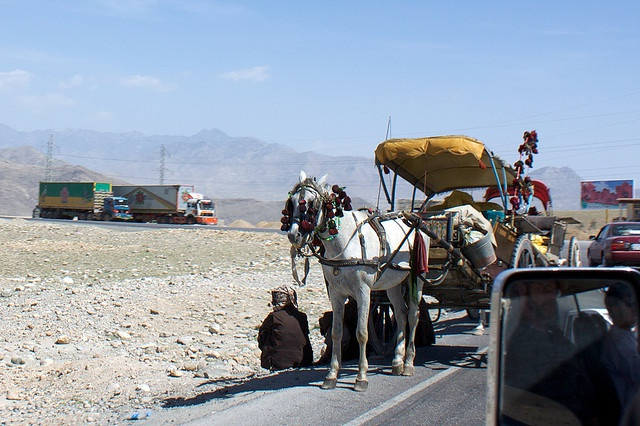Describe the objects in this image and their specific colors. I can see horse in lightblue, gray, black, white, and darkgray tones, people in lightblue, black, and blue tones, people in lightblue, black, gray, and darkblue tones, people in lightblue, black, gray, and maroon tones, and truck in lightblue, gray, black, darkgray, and maroon tones in this image. 